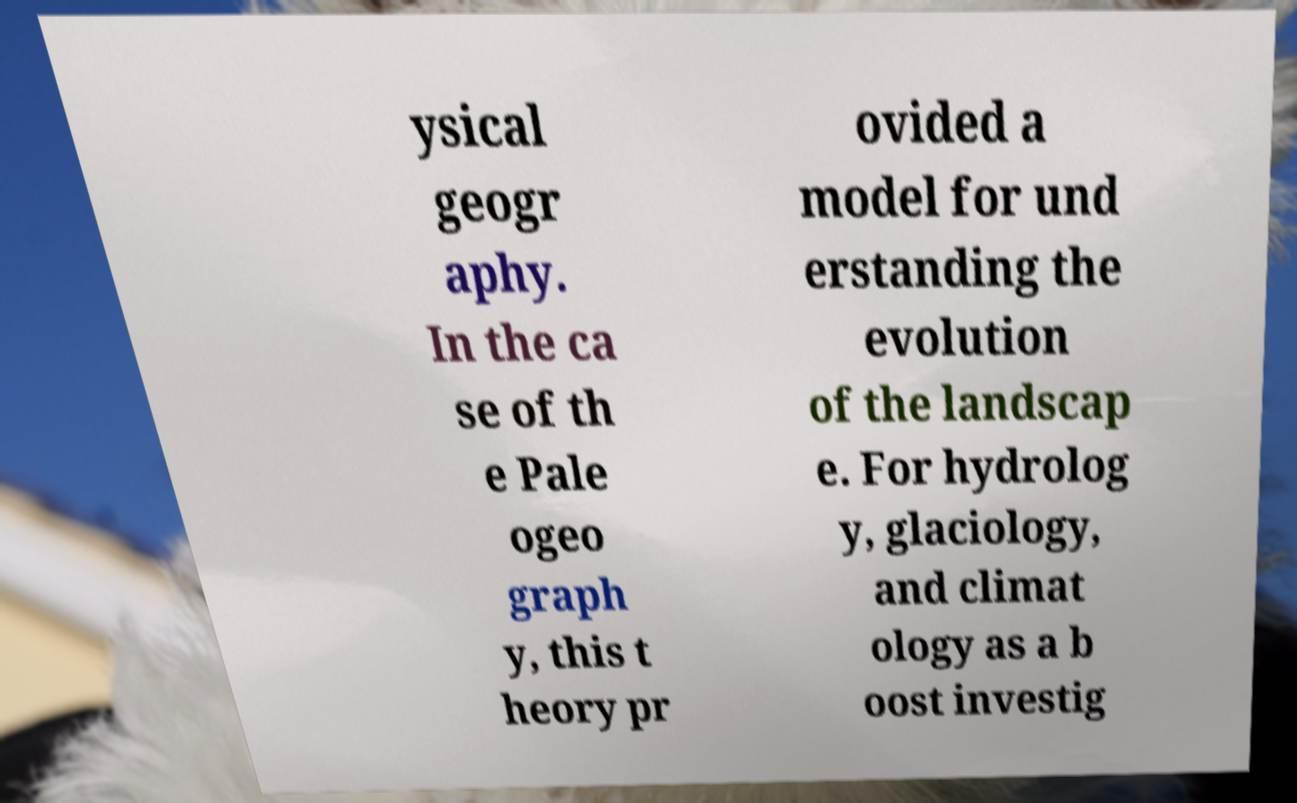Could you extract and type out the text from this image? ysical geogr aphy. In the ca se of th e Pale ogeo graph y, this t heory pr ovided a model for und erstanding the evolution of the landscap e. For hydrolog y, glaciology, and climat ology as a b oost investig 